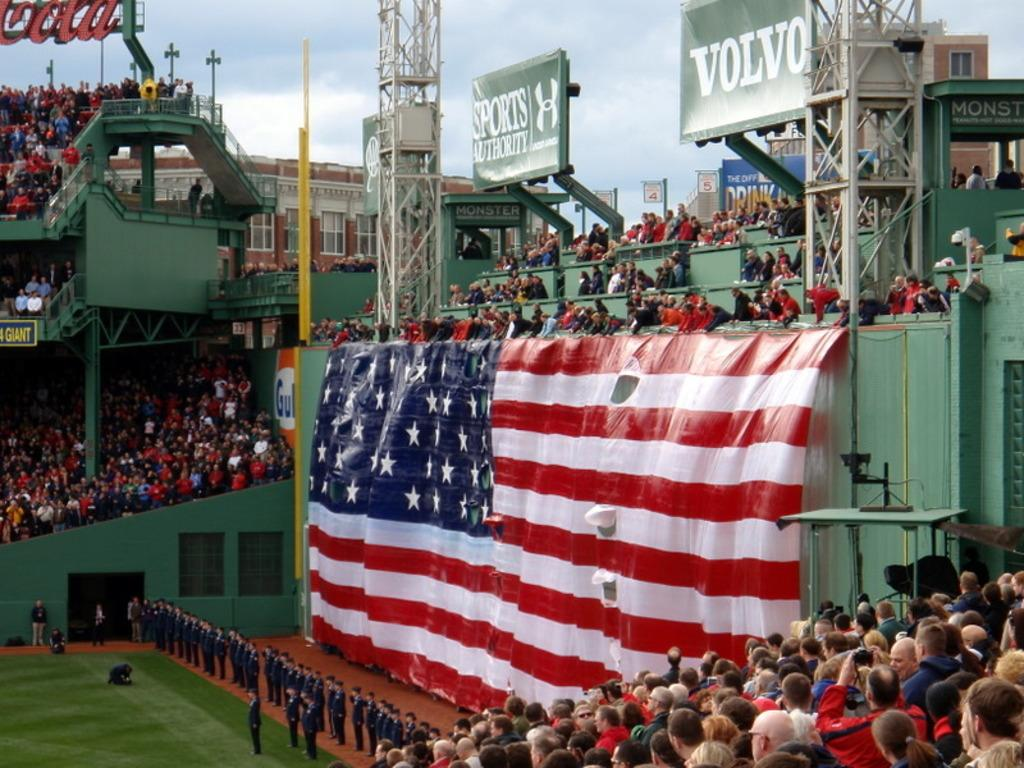Provide a one-sentence caption for the provided image. green colored stadium full of people with large american flag and a volvo sign above it. 